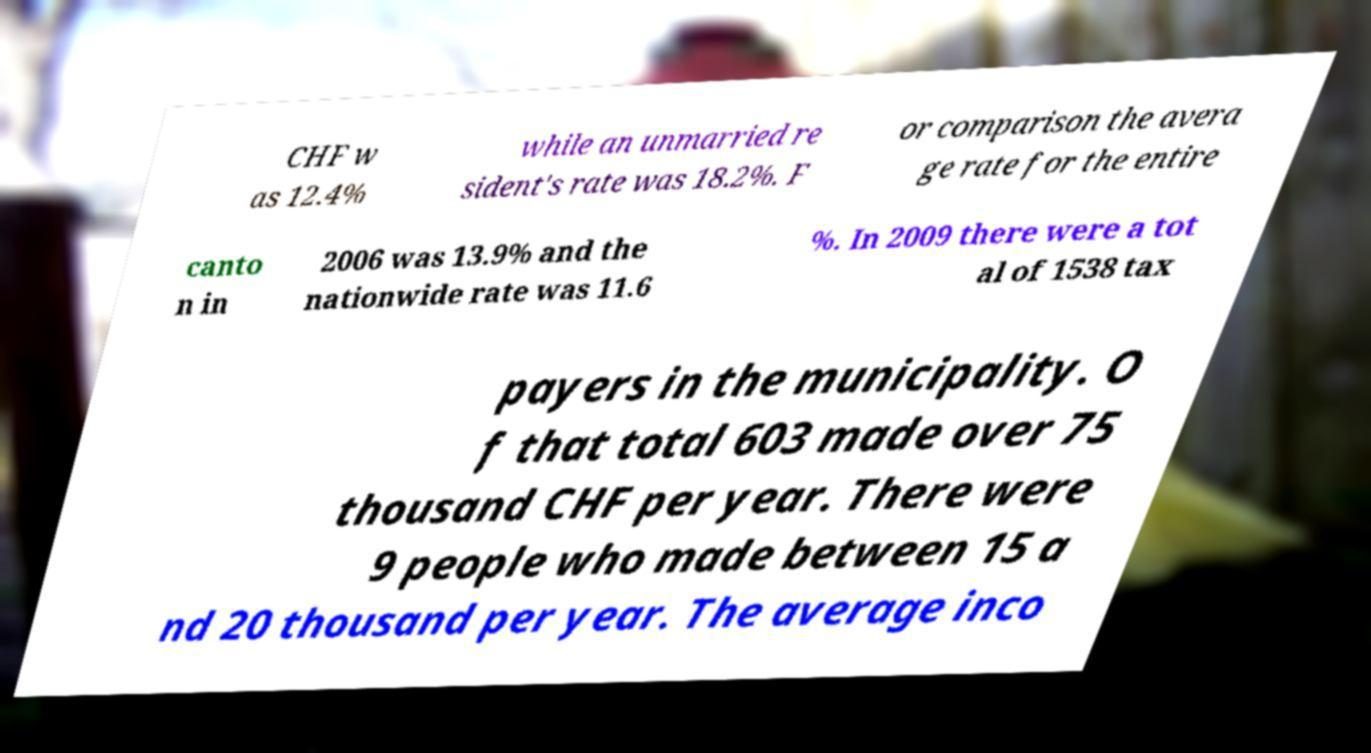For documentation purposes, I need the text within this image transcribed. Could you provide that? CHF w as 12.4% while an unmarried re sident's rate was 18.2%. F or comparison the avera ge rate for the entire canto n in 2006 was 13.9% and the nationwide rate was 11.6 %. In 2009 there were a tot al of 1538 tax payers in the municipality. O f that total 603 made over 75 thousand CHF per year. There were 9 people who made between 15 a nd 20 thousand per year. The average inco 